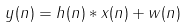<formula> <loc_0><loc_0><loc_500><loc_500>y ( n ) = h ( n ) * x ( n ) + w ( n )</formula> 